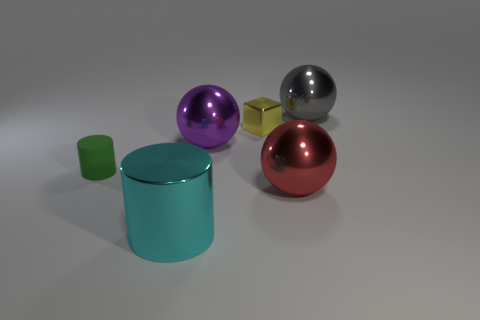The cylinder that is made of the same material as the large purple ball is what color? cyan 